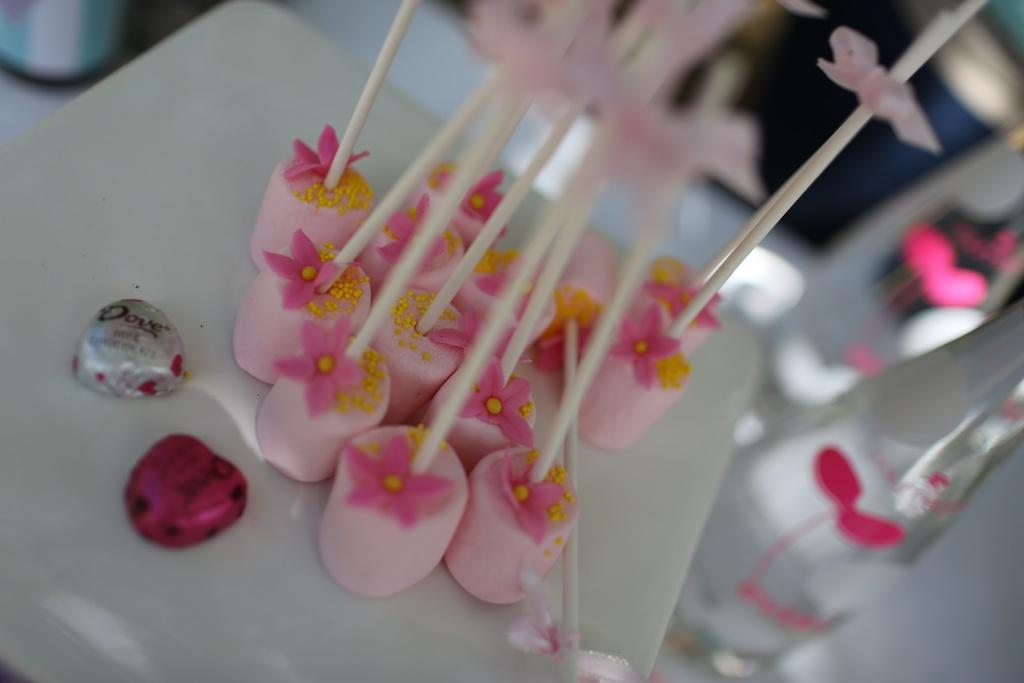What is the color of the surface in the image? The surface in the image is white. What is placed on the white surface? There are candies on the white surface. Can you describe the background of the image? The background of the image is blurred. What else can be seen in the image besides the candies and white surface? There are bottles visible in the image. What is the name of the cattle in the image? There are no cattle present in the image. What type of scale is used to weigh the candies in the image? There is no scale visible in the image, and the candies are not being weighed. 